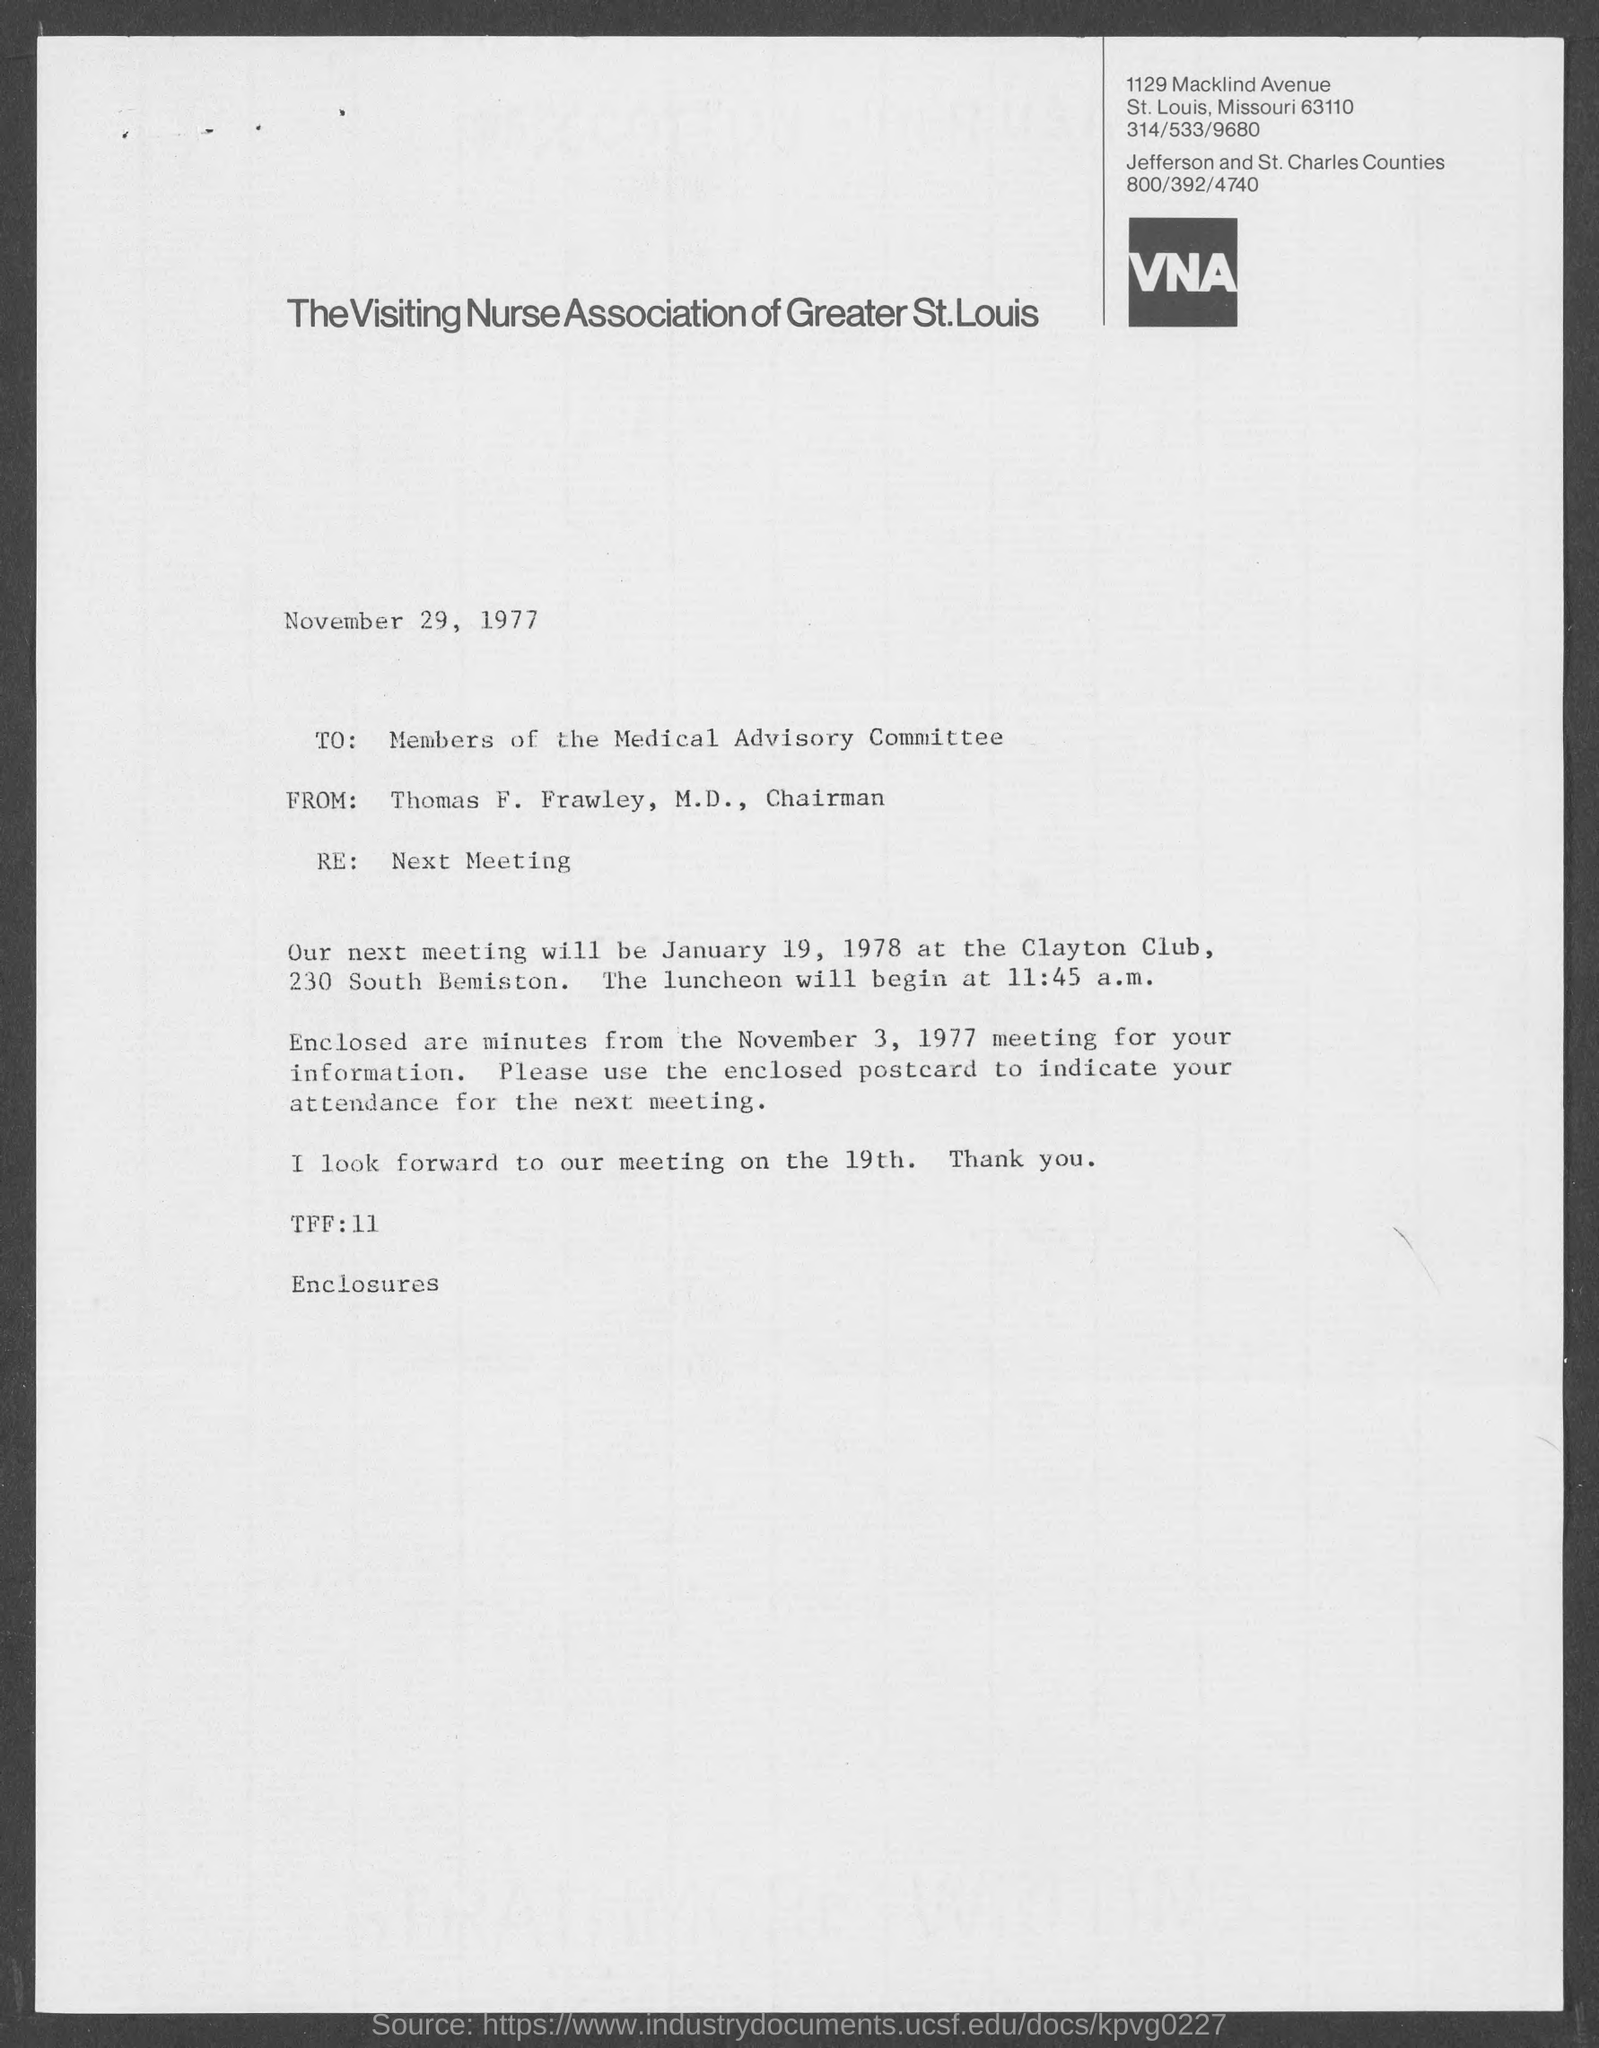Highlight a few significant elements in this photo. The memorandum is dated November 29, 1977. The position of Thomas F. Frawley, M.D., is Chairman. The next meeting is scheduled for January 19, 1978. The Visiting Nurse Association of Greater St. Louis, St. Louis County can be contacted at 314/533/9680. 